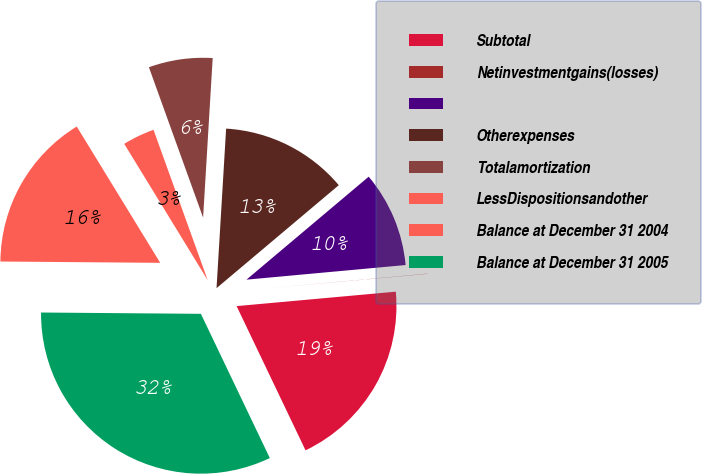Convert chart to OTSL. <chart><loc_0><loc_0><loc_500><loc_500><pie_chart><fcel>Subtotal<fcel>Netinvestmentgains(losses)<fcel>Unnamed: 2<fcel>Otherexpenses<fcel>Totalamortization<fcel>LessDispositionsandother<fcel>Balance at December 31 2004<fcel>Balance at December 31 2005<nl><fcel>19.34%<fcel>0.02%<fcel>9.68%<fcel>12.9%<fcel>6.46%<fcel>3.24%<fcel>16.12%<fcel>32.22%<nl></chart> 